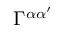Convert formula to latex. <formula><loc_0><loc_0><loc_500><loc_500>\Gamma ^ { \alpha \alpha ^ { \prime } }</formula> 